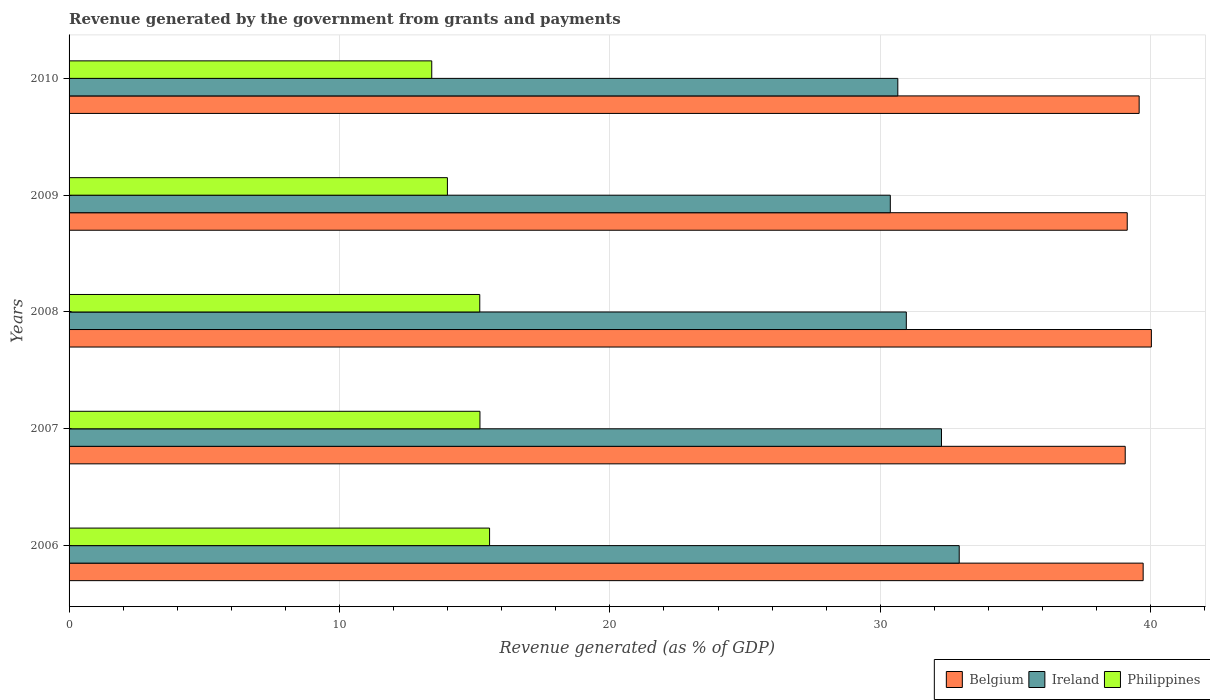How many groups of bars are there?
Provide a short and direct response. 5. Are the number of bars on each tick of the Y-axis equal?
Your answer should be compact. Yes. How many bars are there on the 3rd tick from the top?
Your response must be concise. 3. What is the revenue generated by the government in Belgium in 2009?
Your response must be concise. 39.13. Across all years, what is the maximum revenue generated by the government in Philippines?
Your answer should be compact. 15.55. Across all years, what is the minimum revenue generated by the government in Belgium?
Offer a terse response. 39.06. In which year was the revenue generated by the government in Belgium minimum?
Keep it short and to the point. 2007. What is the total revenue generated by the government in Ireland in the graph?
Keep it short and to the point. 157.16. What is the difference between the revenue generated by the government in Ireland in 2006 and that in 2010?
Make the answer very short. 2.27. What is the difference between the revenue generated by the government in Ireland in 2008 and the revenue generated by the government in Philippines in 2007?
Ensure brevity in your answer.  15.77. What is the average revenue generated by the government in Philippines per year?
Make the answer very short. 14.67. In the year 2007, what is the difference between the revenue generated by the government in Ireland and revenue generated by the government in Belgium?
Your answer should be very brief. -6.8. In how many years, is the revenue generated by the government in Ireland greater than 34 %?
Provide a short and direct response. 0. What is the ratio of the revenue generated by the government in Ireland in 2009 to that in 2010?
Offer a very short reply. 0.99. What is the difference between the highest and the second highest revenue generated by the government in Belgium?
Give a very brief answer. 0.3. What is the difference between the highest and the lowest revenue generated by the government in Belgium?
Offer a very short reply. 0.97. In how many years, is the revenue generated by the government in Ireland greater than the average revenue generated by the government in Ireland taken over all years?
Provide a short and direct response. 2. Is the sum of the revenue generated by the government in Belgium in 2007 and 2010 greater than the maximum revenue generated by the government in Ireland across all years?
Provide a succinct answer. Yes. What does the 3rd bar from the top in 2006 represents?
Offer a very short reply. Belgium. What does the 3rd bar from the bottom in 2009 represents?
Make the answer very short. Philippines. Is it the case that in every year, the sum of the revenue generated by the government in Ireland and revenue generated by the government in Belgium is greater than the revenue generated by the government in Philippines?
Offer a terse response. Yes. How many bars are there?
Your answer should be compact. 15. How many years are there in the graph?
Offer a terse response. 5. Where does the legend appear in the graph?
Provide a succinct answer. Bottom right. How are the legend labels stacked?
Your answer should be very brief. Horizontal. What is the title of the graph?
Provide a succinct answer. Revenue generated by the government from grants and payments. What is the label or title of the X-axis?
Make the answer very short. Revenue generated (as % of GDP). What is the Revenue generated (as % of GDP) of Belgium in 2006?
Make the answer very short. 39.72. What is the Revenue generated (as % of GDP) of Ireland in 2006?
Offer a very short reply. 32.92. What is the Revenue generated (as % of GDP) of Philippines in 2006?
Your answer should be compact. 15.55. What is the Revenue generated (as % of GDP) of Belgium in 2007?
Ensure brevity in your answer.  39.06. What is the Revenue generated (as % of GDP) in Ireland in 2007?
Give a very brief answer. 32.26. What is the Revenue generated (as % of GDP) of Philippines in 2007?
Offer a very short reply. 15.2. What is the Revenue generated (as % of GDP) of Belgium in 2008?
Give a very brief answer. 40.02. What is the Revenue generated (as % of GDP) in Ireland in 2008?
Your response must be concise. 30.96. What is the Revenue generated (as % of GDP) in Philippines in 2008?
Your answer should be very brief. 15.19. What is the Revenue generated (as % of GDP) in Belgium in 2009?
Offer a terse response. 39.13. What is the Revenue generated (as % of GDP) in Ireland in 2009?
Your answer should be very brief. 30.37. What is the Revenue generated (as % of GDP) of Philippines in 2009?
Your response must be concise. 13.99. What is the Revenue generated (as % of GDP) in Belgium in 2010?
Provide a short and direct response. 39.57. What is the Revenue generated (as % of GDP) in Ireland in 2010?
Your answer should be very brief. 30.65. What is the Revenue generated (as % of GDP) of Philippines in 2010?
Provide a succinct answer. 13.41. Across all years, what is the maximum Revenue generated (as % of GDP) of Belgium?
Your answer should be compact. 40.02. Across all years, what is the maximum Revenue generated (as % of GDP) in Ireland?
Provide a succinct answer. 32.92. Across all years, what is the maximum Revenue generated (as % of GDP) in Philippines?
Provide a short and direct response. 15.55. Across all years, what is the minimum Revenue generated (as % of GDP) of Belgium?
Your answer should be compact. 39.06. Across all years, what is the minimum Revenue generated (as % of GDP) in Ireland?
Offer a terse response. 30.37. Across all years, what is the minimum Revenue generated (as % of GDP) of Philippines?
Give a very brief answer. 13.41. What is the total Revenue generated (as % of GDP) of Belgium in the graph?
Offer a terse response. 197.51. What is the total Revenue generated (as % of GDP) of Ireland in the graph?
Provide a succinct answer. 157.16. What is the total Revenue generated (as % of GDP) of Philippines in the graph?
Provide a short and direct response. 73.34. What is the difference between the Revenue generated (as % of GDP) in Belgium in 2006 and that in 2007?
Your answer should be compact. 0.66. What is the difference between the Revenue generated (as % of GDP) of Ireland in 2006 and that in 2007?
Offer a very short reply. 0.66. What is the difference between the Revenue generated (as % of GDP) in Philippines in 2006 and that in 2007?
Provide a short and direct response. 0.36. What is the difference between the Revenue generated (as % of GDP) in Belgium in 2006 and that in 2008?
Provide a succinct answer. -0.3. What is the difference between the Revenue generated (as % of GDP) in Ireland in 2006 and that in 2008?
Offer a very short reply. 1.96. What is the difference between the Revenue generated (as % of GDP) in Philippines in 2006 and that in 2008?
Your response must be concise. 0.36. What is the difference between the Revenue generated (as % of GDP) in Belgium in 2006 and that in 2009?
Ensure brevity in your answer.  0.59. What is the difference between the Revenue generated (as % of GDP) in Ireland in 2006 and that in 2009?
Keep it short and to the point. 2.55. What is the difference between the Revenue generated (as % of GDP) in Philippines in 2006 and that in 2009?
Your response must be concise. 1.56. What is the difference between the Revenue generated (as % of GDP) in Belgium in 2006 and that in 2010?
Your response must be concise. 0.15. What is the difference between the Revenue generated (as % of GDP) of Ireland in 2006 and that in 2010?
Make the answer very short. 2.27. What is the difference between the Revenue generated (as % of GDP) of Philippines in 2006 and that in 2010?
Ensure brevity in your answer.  2.14. What is the difference between the Revenue generated (as % of GDP) in Belgium in 2007 and that in 2008?
Give a very brief answer. -0.97. What is the difference between the Revenue generated (as % of GDP) of Ireland in 2007 and that in 2008?
Provide a short and direct response. 1.3. What is the difference between the Revenue generated (as % of GDP) in Philippines in 2007 and that in 2008?
Ensure brevity in your answer.  0.01. What is the difference between the Revenue generated (as % of GDP) in Belgium in 2007 and that in 2009?
Provide a succinct answer. -0.07. What is the difference between the Revenue generated (as % of GDP) of Ireland in 2007 and that in 2009?
Make the answer very short. 1.89. What is the difference between the Revenue generated (as % of GDP) of Philippines in 2007 and that in 2009?
Your answer should be very brief. 1.2. What is the difference between the Revenue generated (as % of GDP) in Belgium in 2007 and that in 2010?
Offer a very short reply. -0.52. What is the difference between the Revenue generated (as % of GDP) in Ireland in 2007 and that in 2010?
Ensure brevity in your answer.  1.62. What is the difference between the Revenue generated (as % of GDP) of Philippines in 2007 and that in 2010?
Make the answer very short. 1.78. What is the difference between the Revenue generated (as % of GDP) of Belgium in 2008 and that in 2009?
Make the answer very short. 0.89. What is the difference between the Revenue generated (as % of GDP) of Ireland in 2008 and that in 2009?
Your answer should be compact. 0.59. What is the difference between the Revenue generated (as % of GDP) of Philippines in 2008 and that in 2009?
Provide a succinct answer. 1.2. What is the difference between the Revenue generated (as % of GDP) of Belgium in 2008 and that in 2010?
Give a very brief answer. 0.45. What is the difference between the Revenue generated (as % of GDP) in Ireland in 2008 and that in 2010?
Your answer should be compact. 0.31. What is the difference between the Revenue generated (as % of GDP) in Philippines in 2008 and that in 2010?
Provide a succinct answer. 1.78. What is the difference between the Revenue generated (as % of GDP) in Belgium in 2009 and that in 2010?
Provide a short and direct response. -0.44. What is the difference between the Revenue generated (as % of GDP) in Ireland in 2009 and that in 2010?
Provide a short and direct response. -0.28. What is the difference between the Revenue generated (as % of GDP) of Philippines in 2009 and that in 2010?
Keep it short and to the point. 0.58. What is the difference between the Revenue generated (as % of GDP) in Belgium in 2006 and the Revenue generated (as % of GDP) in Ireland in 2007?
Keep it short and to the point. 7.46. What is the difference between the Revenue generated (as % of GDP) in Belgium in 2006 and the Revenue generated (as % of GDP) in Philippines in 2007?
Give a very brief answer. 24.53. What is the difference between the Revenue generated (as % of GDP) of Ireland in 2006 and the Revenue generated (as % of GDP) of Philippines in 2007?
Provide a short and direct response. 17.72. What is the difference between the Revenue generated (as % of GDP) of Belgium in 2006 and the Revenue generated (as % of GDP) of Ireland in 2008?
Your answer should be compact. 8.76. What is the difference between the Revenue generated (as % of GDP) of Belgium in 2006 and the Revenue generated (as % of GDP) of Philippines in 2008?
Make the answer very short. 24.53. What is the difference between the Revenue generated (as % of GDP) of Ireland in 2006 and the Revenue generated (as % of GDP) of Philippines in 2008?
Give a very brief answer. 17.73. What is the difference between the Revenue generated (as % of GDP) in Belgium in 2006 and the Revenue generated (as % of GDP) in Ireland in 2009?
Offer a terse response. 9.35. What is the difference between the Revenue generated (as % of GDP) in Belgium in 2006 and the Revenue generated (as % of GDP) in Philippines in 2009?
Your answer should be very brief. 25.73. What is the difference between the Revenue generated (as % of GDP) of Ireland in 2006 and the Revenue generated (as % of GDP) of Philippines in 2009?
Your answer should be very brief. 18.93. What is the difference between the Revenue generated (as % of GDP) in Belgium in 2006 and the Revenue generated (as % of GDP) in Ireland in 2010?
Your answer should be compact. 9.07. What is the difference between the Revenue generated (as % of GDP) in Belgium in 2006 and the Revenue generated (as % of GDP) in Philippines in 2010?
Give a very brief answer. 26.31. What is the difference between the Revenue generated (as % of GDP) of Ireland in 2006 and the Revenue generated (as % of GDP) of Philippines in 2010?
Make the answer very short. 19.51. What is the difference between the Revenue generated (as % of GDP) of Belgium in 2007 and the Revenue generated (as % of GDP) of Ireland in 2008?
Make the answer very short. 8.1. What is the difference between the Revenue generated (as % of GDP) in Belgium in 2007 and the Revenue generated (as % of GDP) in Philippines in 2008?
Offer a terse response. 23.87. What is the difference between the Revenue generated (as % of GDP) in Ireland in 2007 and the Revenue generated (as % of GDP) in Philippines in 2008?
Keep it short and to the point. 17.07. What is the difference between the Revenue generated (as % of GDP) in Belgium in 2007 and the Revenue generated (as % of GDP) in Ireland in 2009?
Provide a short and direct response. 8.69. What is the difference between the Revenue generated (as % of GDP) in Belgium in 2007 and the Revenue generated (as % of GDP) in Philippines in 2009?
Keep it short and to the point. 25.07. What is the difference between the Revenue generated (as % of GDP) of Ireland in 2007 and the Revenue generated (as % of GDP) of Philippines in 2009?
Provide a succinct answer. 18.27. What is the difference between the Revenue generated (as % of GDP) of Belgium in 2007 and the Revenue generated (as % of GDP) of Ireland in 2010?
Provide a succinct answer. 8.41. What is the difference between the Revenue generated (as % of GDP) of Belgium in 2007 and the Revenue generated (as % of GDP) of Philippines in 2010?
Give a very brief answer. 25.65. What is the difference between the Revenue generated (as % of GDP) in Ireland in 2007 and the Revenue generated (as % of GDP) in Philippines in 2010?
Ensure brevity in your answer.  18.85. What is the difference between the Revenue generated (as % of GDP) of Belgium in 2008 and the Revenue generated (as % of GDP) of Ireland in 2009?
Offer a terse response. 9.65. What is the difference between the Revenue generated (as % of GDP) in Belgium in 2008 and the Revenue generated (as % of GDP) in Philippines in 2009?
Offer a terse response. 26.03. What is the difference between the Revenue generated (as % of GDP) of Ireland in 2008 and the Revenue generated (as % of GDP) of Philippines in 2009?
Make the answer very short. 16.97. What is the difference between the Revenue generated (as % of GDP) of Belgium in 2008 and the Revenue generated (as % of GDP) of Ireland in 2010?
Offer a very short reply. 9.38. What is the difference between the Revenue generated (as % of GDP) of Belgium in 2008 and the Revenue generated (as % of GDP) of Philippines in 2010?
Keep it short and to the point. 26.61. What is the difference between the Revenue generated (as % of GDP) in Ireland in 2008 and the Revenue generated (as % of GDP) in Philippines in 2010?
Provide a succinct answer. 17.55. What is the difference between the Revenue generated (as % of GDP) in Belgium in 2009 and the Revenue generated (as % of GDP) in Ireland in 2010?
Provide a short and direct response. 8.48. What is the difference between the Revenue generated (as % of GDP) of Belgium in 2009 and the Revenue generated (as % of GDP) of Philippines in 2010?
Offer a terse response. 25.72. What is the difference between the Revenue generated (as % of GDP) of Ireland in 2009 and the Revenue generated (as % of GDP) of Philippines in 2010?
Your answer should be compact. 16.96. What is the average Revenue generated (as % of GDP) of Belgium per year?
Offer a very short reply. 39.5. What is the average Revenue generated (as % of GDP) in Ireland per year?
Offer a terse response. 31.43. What is the average Revenue generated (as % of GDP) in Philippines per year?
Give a very brief answer. 14.67. In the year 2006, what is the difference between the Revenue generated (as % of GDP) in Belgium and Revenue generated (as % of GDP) in Ireland?
Your response must be concise. 6.8. In the year 2006, what is the difference between the Revenue generated (as % of GDP) in Belgium and Revenue generated (as % of GDP) in Philippines?
Your answer should be very brief. 24.17. In the year 2006, what is the difference between the Revenue generated (as % of GDP) of Ireland and Revenue generated (as % of GDP) of Philippines?
Your answer should be compact. 17.37. In the year 2007, what is the difference between the Revenue generated (as % of GDP) of Belgium and Revenue generated (as % of GDP) of Ireland?
Offer a terse response. 6.8. In the year 2007, what is the difference between the Revenue generated (as % of GDP) in Belgium and Revenue generated (as % of GDP) in Philippines?
Give a very brief answer. 23.86. In the year 2007, what is the difference between the Revenue generated (as % of GDP) of Ireland and Revenue generated (as % of GDP) of Philippines?
Your response must be concise. 17.07. In the year 2008, what is the difference between the Revenue generated (as % of GDP) in Belgium and Revenue generated (as % of GDP) in Ireland?
Keep it short and to the point. 9.06. In the year 2008, what is the difference between the Revenue generated (as % of GDP) of Belgium and Revenue generated (as % of GDP) of Philippines?
Offer a very short reply. 24.84. In the year 2008, what is the difference between the Revenue generated (as % of GDP) in Ireland and Revenue generated (as % of GDP) in Philippines?
Your answer should be compact. 15.77. In the year 2009, what is the difference between the Revenue generated (as % of GDP) in Belgium and Revenue generated (as % of GDP) in Ireland?
Ensure brevity in your answer.  8.76. In the year 2009, what is the difference between the Revenue generated (as % of GDP) of Belgium and Revenue generated (as % of GDP) of Philippines?
Ensure brevity in your answer.  25.14. In the year 2009, what is the difference between the Revenue generated (as % of GDP) of Ireland and Revenue generated (as % of GDP) of Philippines?
Make the answer very short. 16.38. In the year 2010, what is the difference between the Revenue generated (as % of GDP) in Belgium and Revenue generated (as % of GDP) in Ireland?
Keep it short and to the point. 8.93. In the year 2010, what is the difference between the Revenue generated (as % of GDP) of Belgium and Revenue generated (as % of GDP) of Philippines?
Offer a very short reply. 26.16. In the year 2010, what is the difference between the Revenue generated (as % of GDP) of Ireland and Revenue generated (as % of GDP) of Philippines?
Make the answer very short. 17.24. What is the ratio of the Revenue generated (as % of GDP) in Ireland in 2006 to that in 2007?
Make the answer very short. 1.02. What is the ratio of the Revenue generated (as % of GDP) in Philippines in 2006 to that in 2007?
Your answer should be very brief. 1.02. What is the ratio of the Revenue generated (as % of GDP) of Ireland in 2006 to that in 2008?
Give a very brief answer. 1.06. What is the ratio of the Revenue generated (as % of GDP) in Philippines in 2006 to that in 2008?
Your answer should be compact. 1.02. What is the ratio of the Revenue generated (as % of GDP) in Belgium in 2006 to that in 2009?
Provide a succinct answer. 1.01. What is the ratio of the Revenue generated (as % of GDP) of Ireland in 2006 to that in 2009?
Your answer should be very brief. 1.08. What is the ratio of the Revenue generated (as % of GDP) in Philippines in 2006 to that in 2009?
Ensure brevity in your answer.  1.11. What is the ratio of the Revenue generated (as % of GDP) in Belgium in 2006 to that in 2010?
Your answer should be very brief. 1. What is the ratio of the Revenue generated (as % of GDP) in Ireland in 2006 to that in 2010?
Ensure brevity in your answer.  1.07. What is the ratio of the Revenue generated (as % of GDP) of Philippines in 2006 to that in 2010?
Give a very brief answer. 1.16. What is the ratio of the Revenue generated (as % of GDP) of Belgium in 2007 to that in 2008?
Provide a succinct answer. 0.98. What is the ratio of the Revenue generated (as % of GDP) in Ireland in 2007 to that in 2008?
Make the answer very short. 1.04. What is the ratio of the Revenue generated (as % of GDP) in Belgium in 2007 to that in 2009?
Your response must be concise. 1. What is the ratio of the Revenue generated (as % of GDP) of Ireland in 2007 to that in 2009?
Give a very brief answer. 1.06. What is the ratio of the Revenue generated (as % of GDP) of Philippines in 2007 to that in 2009?
Offer a very short reply. 1.09. What is the ratio of the Revenue generated (as % of GDP) of Ireland in 2007 to that in 2010?
Your response must be concise. 1.05. What is the ratio of the Revenue generated (as % of GDP) in Philippines in 2007 to that in 2010?
Keep it short and to the point. 1.13. What is the ratio of the Revenue generated (as % of GDP) in Belgium in 2008 to that in 2009?
Provide a short and direct response. 1.02. What is the ratio of the Revenue generated (as % of GDP) of Ireland in 2008 to that in 2009?
Provide a succinct answer. 1.02. What is the ratio of the Revenue generated (as % of GDP) of Philippines in 2008 to that in 2009?
Keep it short and to the point. 1.09. What is the ratio of the Revenue generated (as % of GDP) in Belgium in 2008 to that in 2010?
Your response must be concise. 1.01. What is the ratio of the Revenue generated (as % of GDP) in Ireland in 2008 to that in 2010?
Ensure brevity in your answer.  1.01. What is the ratio of the Revenue generated (as % of GDP) of Philippines in 2008 to that in 2010?
Keep it short and to the point. 1.13. What is the ratio of the Revenue generated (as % of GDP) of Belgium in 2009 to that in 2010?
Keep it short and to the point. 0.99. What is the ratio of the Revenue generated (as % of GDP) in Philippines in 2009 to that in 2010?
Keep it short and to the point. 1.04. What is the difference between the highest and the second highest Revenue generated (as % of GDP) in Belgium?
Ensure brevity in your answer.  0.3. What is the difference between the highest and the second highest Revenue generated (as % of GDP) in Ireland?
Your response must be concise. 0.66. What is the difference between the highest and the second highest Revenue generated (as % of GDP) of Philippines?
Offer a terse response. 0.36. What is the difference between the highest and the lowest Revenue generated (as % of GDP) of Belgium?
Offer a terse response. 0.97. What is the difference between the highest and the lowest Revenue generated (as % of GDP) of Ireland?
Ensure brevity in your answer.  2.55. What is the difference between the highest and the lowest Revenue generated (as % of GDP) of Philippines?
Offer a terse response. 2.14. 